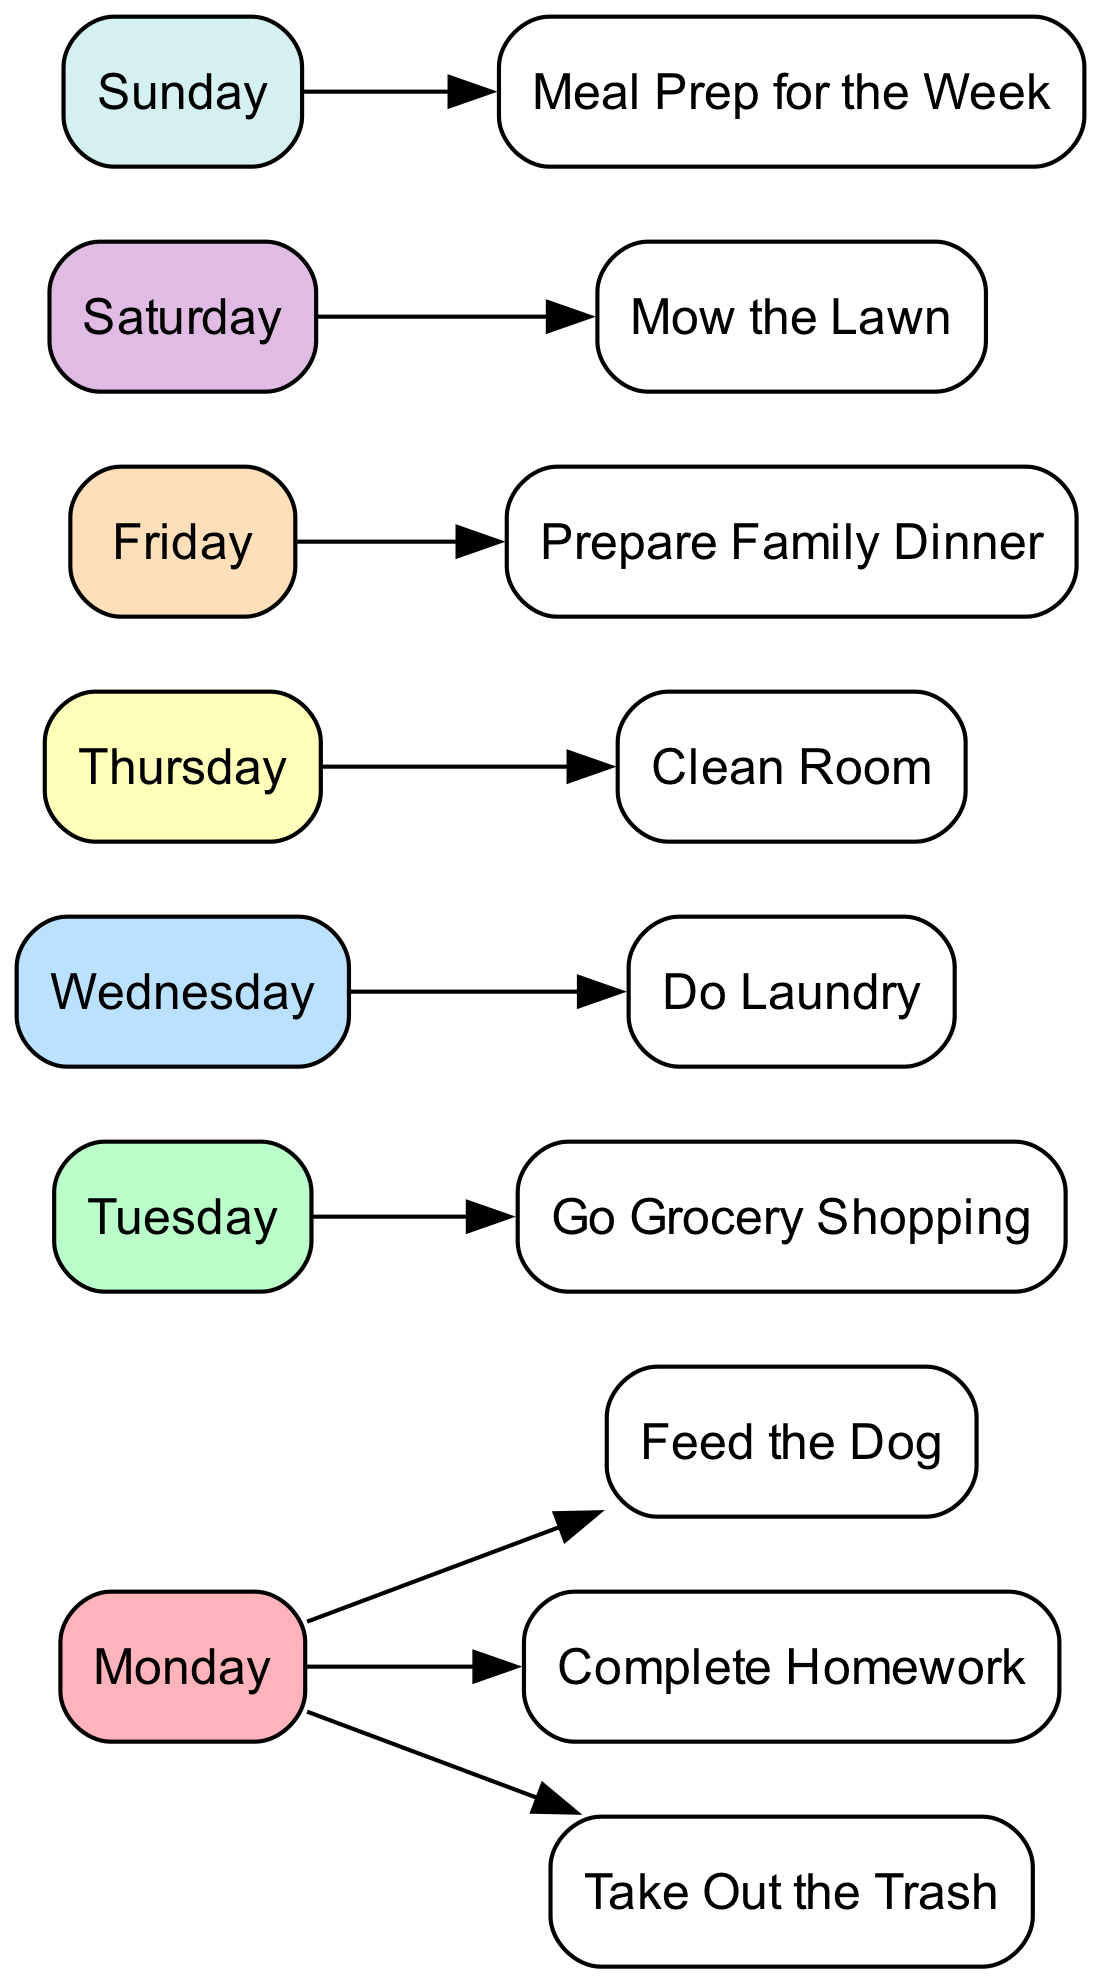What chores are assigned for Monday? The nodes connected to the "Monday" node represent the chores assigned for that day. These chores are "Feed the Dog," "Complete Homework," and "Take Out the Trash."
Answer: Feed the Dog, Complete Homework, Take Out the Trash How many days of the week are represented in this diagram? The diagram features a node for each day of the week (Monday, Tuesday, Wednesday, Thursday, Friday, Saturday, Sunday)—a total of 7 nodes.
Answer: 7 Which day is associated with doing laundry? The "Laundry" chore is connected to the "Wednesday" node, indicating that doing laundry is scheduled for that day.
Answer: Wednesday What is the chore associated with Friday? The node labeled "Family Dinner" is connected to the "Friday" node, indicating that preparing the family dinner is the chore assigned for that day.
Answer: Prepare Family Dinner Which chore is performed on Sunday? The "Meal Prep for the Week" chore is linked to the "Sunday" node, indicating that this activity is scheduled for Sunday.
Answer: Meal Prep for the Week How many chores are assigned to Tuesday? The diagram shows only one node, "Grocery," linked to the "Tuesday" node, which means there is one chore assigned for that day.
Answer: 1 What is the relationship between Thursday and the assigned chores? The "Clean Room" chore is the only chore shown connected by an edge to the "Thursday" node, indicating that this is the sole responsibility for that day.
Answer: Clean Room On which day does the older child mow the lawn? The "Yard Work" chore is linked to the "Saturday" node, showing that the older child is responsible for mowing the lawn on Saturday.
Answer: Saturday Which chore connects to Monday and is also performed during the week? The "Complete Homework" chore is connected to Monday and indicates a responsibility that recurs within the week, making it part of the daily routine.
Answer: Complete Homework 